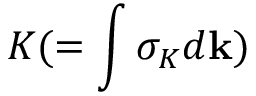<formula> <loc_0><loc_0><loc_500><loc_500>K ( = \int \sigma _ { K } d { k } )</formula> 